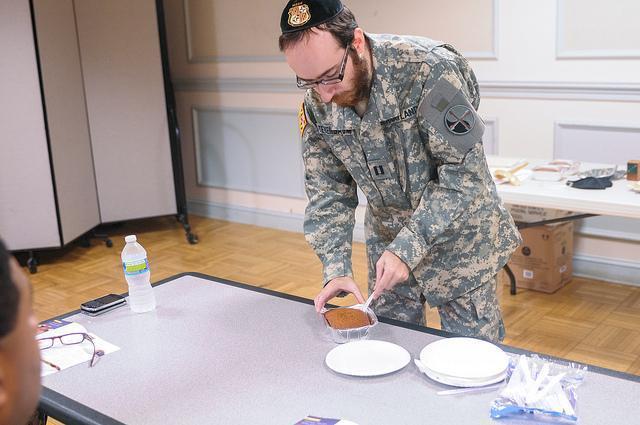How many people can you see?
Give a very brief answer. 2. 